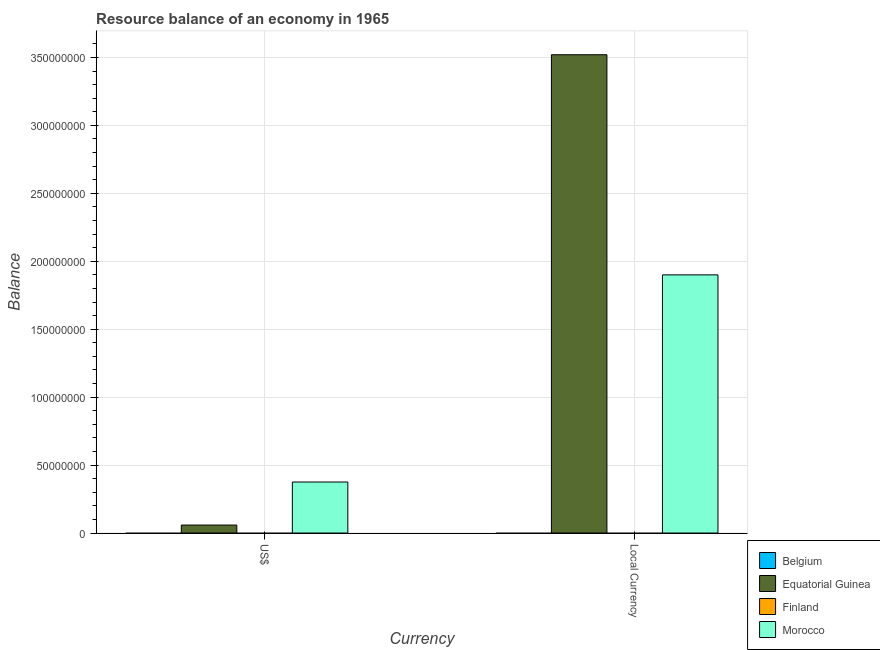Are the number of bars on each tick of the X-axis equal?
Give a very brief answer. Yes. How many bars are there on the 1st tick from the right?
Offer a terse response. 2. What is the label of the 1st group of bars from the left?
Offer a terse response. US$. What is the resource balance in us$ in Finland?
Give a very brief answer. 0. Across all countries, what is the maximum resource balance in us$?
Give a very brief answer. 3.75e+07. In which country was the resource balance in us$ maximum?
Offer a very short reply. Morocco. What is the total resource balance in constant us$ in the graph?
Your response must be concise. 5.42e+08. What is the difference between the resource balance in constant us$ in Equatorial Guinea and that in Morocco?
Offer a terse response. 1.62e+08. What is the difference between the resource balance in constant us$ in Morocco and the resource balance in us$ in Finland?
Provide a succinct answer. 1.90e+08. What is the average resource balance in constant us$ per country?
Your response must be concise. 1.36e+08. What is the difference between the resource balance in constant us$ and resource balance in us$ in Morocco?
Keep it short and to the point. 1.52e+08. In how many countries, is the resource balance in constant us$ greater than 250000000 units?
Your answer should be very brief. 1. What is the difference between two consecutive major ticks on the Y-axis?
Offer a very short reply. 5.00e+07. Does the graph contain grids?
Your answer should be compact. Yes. Where does the legend appear in the graph?
Ensure brevity in your answer.  Bottom right. How are the legend labels stacked?
Your answer should be very brief. Vertical. What is the title of the graph?
Offer a terse response. Resource balance of an economy in 1965. Does "Nepal" appear as one of the legend labels in the graph?
Provide a succinct answer. No. What is the label or title of the X-axis?
Your response must be concise. Currency. What is the label or title of the Y-axis?
Your answer should be compact. Balance. What is the Balance in Belgium in US$?
Provide a succinct answer. 0. What is the Balance of Equatorial Guinea in US$?
Keep it short and to the point. 5.87e+06. What is the Balance in Finland in US$?
Provide a succinct answer. 0. What is the Balance in Morocco in US$?
Provide a succinct answer. 3.75e+07. What is the Balance in Belgium in Local Currency?
Make the answer very short. 0. What is the Balance of Equatorial Guinea in Local Currency?
Offer a terse response. 3.52e+08. What is the Balance in Finland in Local Currency?
Offer a terse response. 0. What is the Balance of Morocco in Local Currency?
Make the answer very short. 1.90e+08. Across all Currency, what is the maximum Balance in Equatorial Guinea?
Your response must be concise. 3.52e+08. Across all Currency, what is the maximum Balance of Morocco?
Ensure brevity in your answer.  1.90e+08. Across all Currency, what is the minimum Balance in Equatorial Guinea?
Provide a succinct answer. 5.87e+06. Across all Currency, what is the minimum Balance in Morocco?
Provide a short and direct response. 3.75e+07. What is the total Balance in Belgium in the graph?
Your answer should be compact. 0. What is the total Balance of Equatorial Guinea in the graph?
Give a very brief answer. 3.58e+08. What is the total Balance in Finland in the graph?
Make the answer very short. 0. What is the total Balance of Morocco in the graph?
Your response must be concise. 2.28e+08. What is the difference between the Balance of Equatorial Guinea in US$ and that in Local Currency?
Provide a short and direct response. -3.46e+08. What is the difference between the Balance in Morocco in US$ and that in Local Currency?
Ensure brevity in your answer.  -1.52e+08. What is the difference between the Balance of Equatorial Guinea in US$ and the Balance of Morocco in Local Currency?
Keep it short and to the point. -1.84e+08. What is the average Balance of Equatorial Guinea per Currency?
Provide a succinct answer. 1.79e+08. What is the average Balance in Finland per Currency?
Keep it short and to the point. 0. What is the average Balance of Morocco per Currency?
Provide a succinct answer. 1.14e+08. What is the difference between the Balance of Equatorial Guinea and Balance of Morocco in US$?
Give a very brief answer. -3.17e+07. What is the difference between the Balance in Equatorial Guinea and Balance in Morocco in Local Currency?
Your answer should be very brief. 1.62e+08. What is the ratio of the Balance in Equatorial Guinea in US$ to that in Local Currency?
Give a very brief answer. 0.02. What is the ratio of the Balance in Morocco in US$ to that in Local Currency?
Offer a terse response. 0.2. What is the difference between the highest and the second highest Balance in Equatorial Guinea?
Ensure brevity in your answer.  3.46e+08. What is the difference between the highest and the second highest Balance in Morocco?
Provide a succinct answer. 1.52e+08. What is the difference between the highest and the lowest Balance of Equatorial Guinea?
Your answer should be very brief. 3.46e+08. What is the difference between the highest and the lowest Balance of Morocco?
Your answer should be very brief. 1.52e+08. 